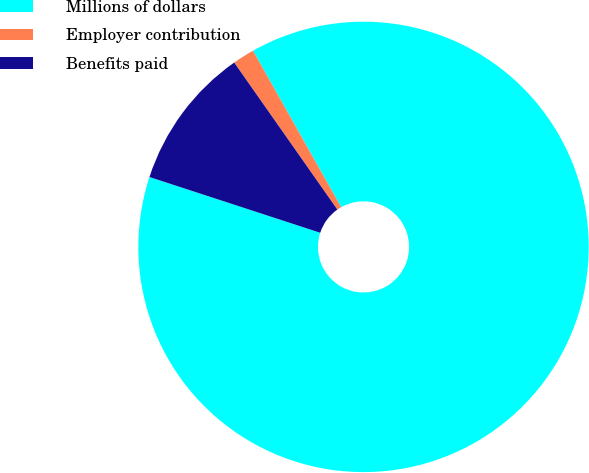Convert chart to OTSL. <chart><loc_0><loc_0><loc_500><loc_500><pie_chart><fcel>Millions of dollars<fcel>Employer contribution<fcel>Benefits paid<nl><fcel>88.19%<fcel>1.57%<fcel>10.24%<nl></chart> 